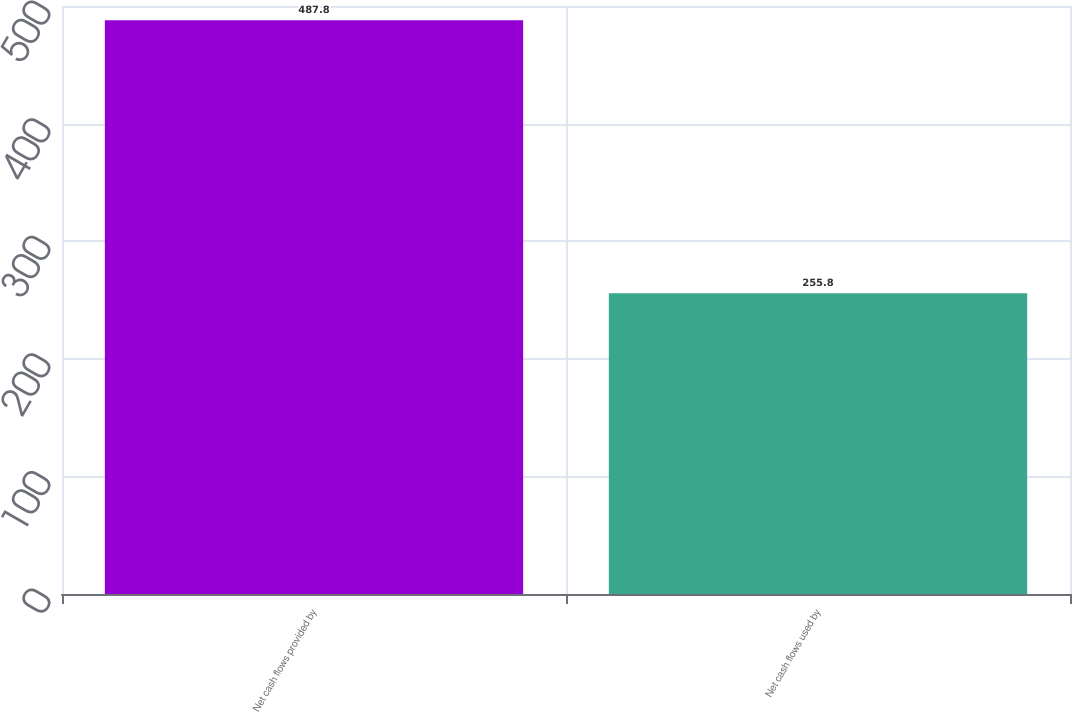<chart> <loc_0><loc_0><loc_500><loc_500><bar_chart><fcel>Net cash flows provided by<fcel>Net cash flows used by<nl><fcel>487.8<fcel>255.8<nl></chart> 